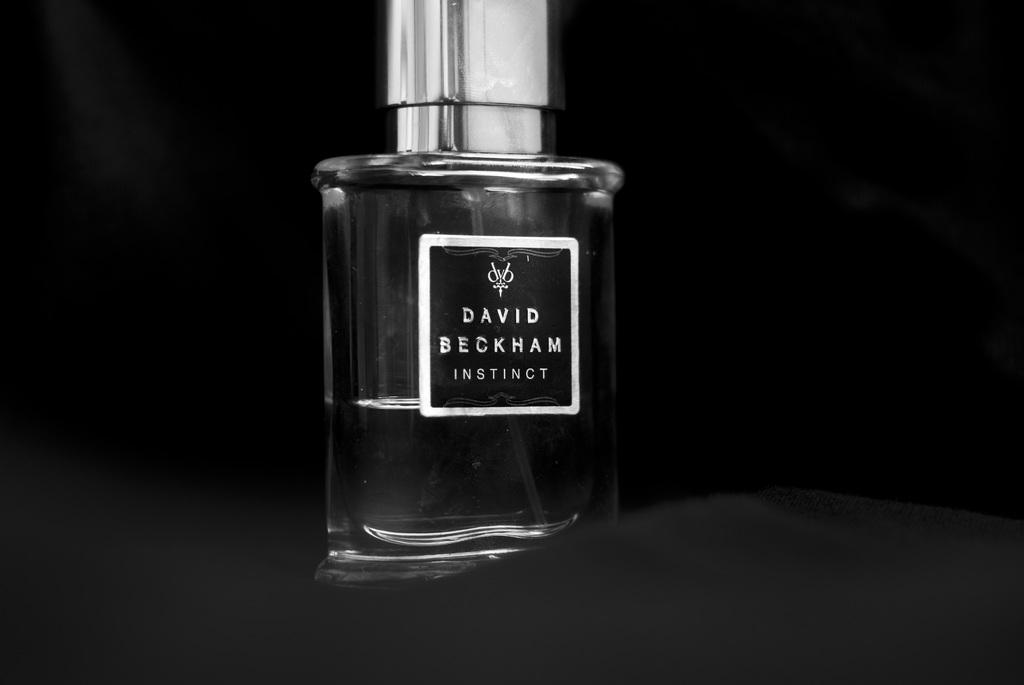What is beckham's cologne named?
Offer a very short reply. Instinct. Who's name is on the cologne?
Your answer should be compact. David beckham. 